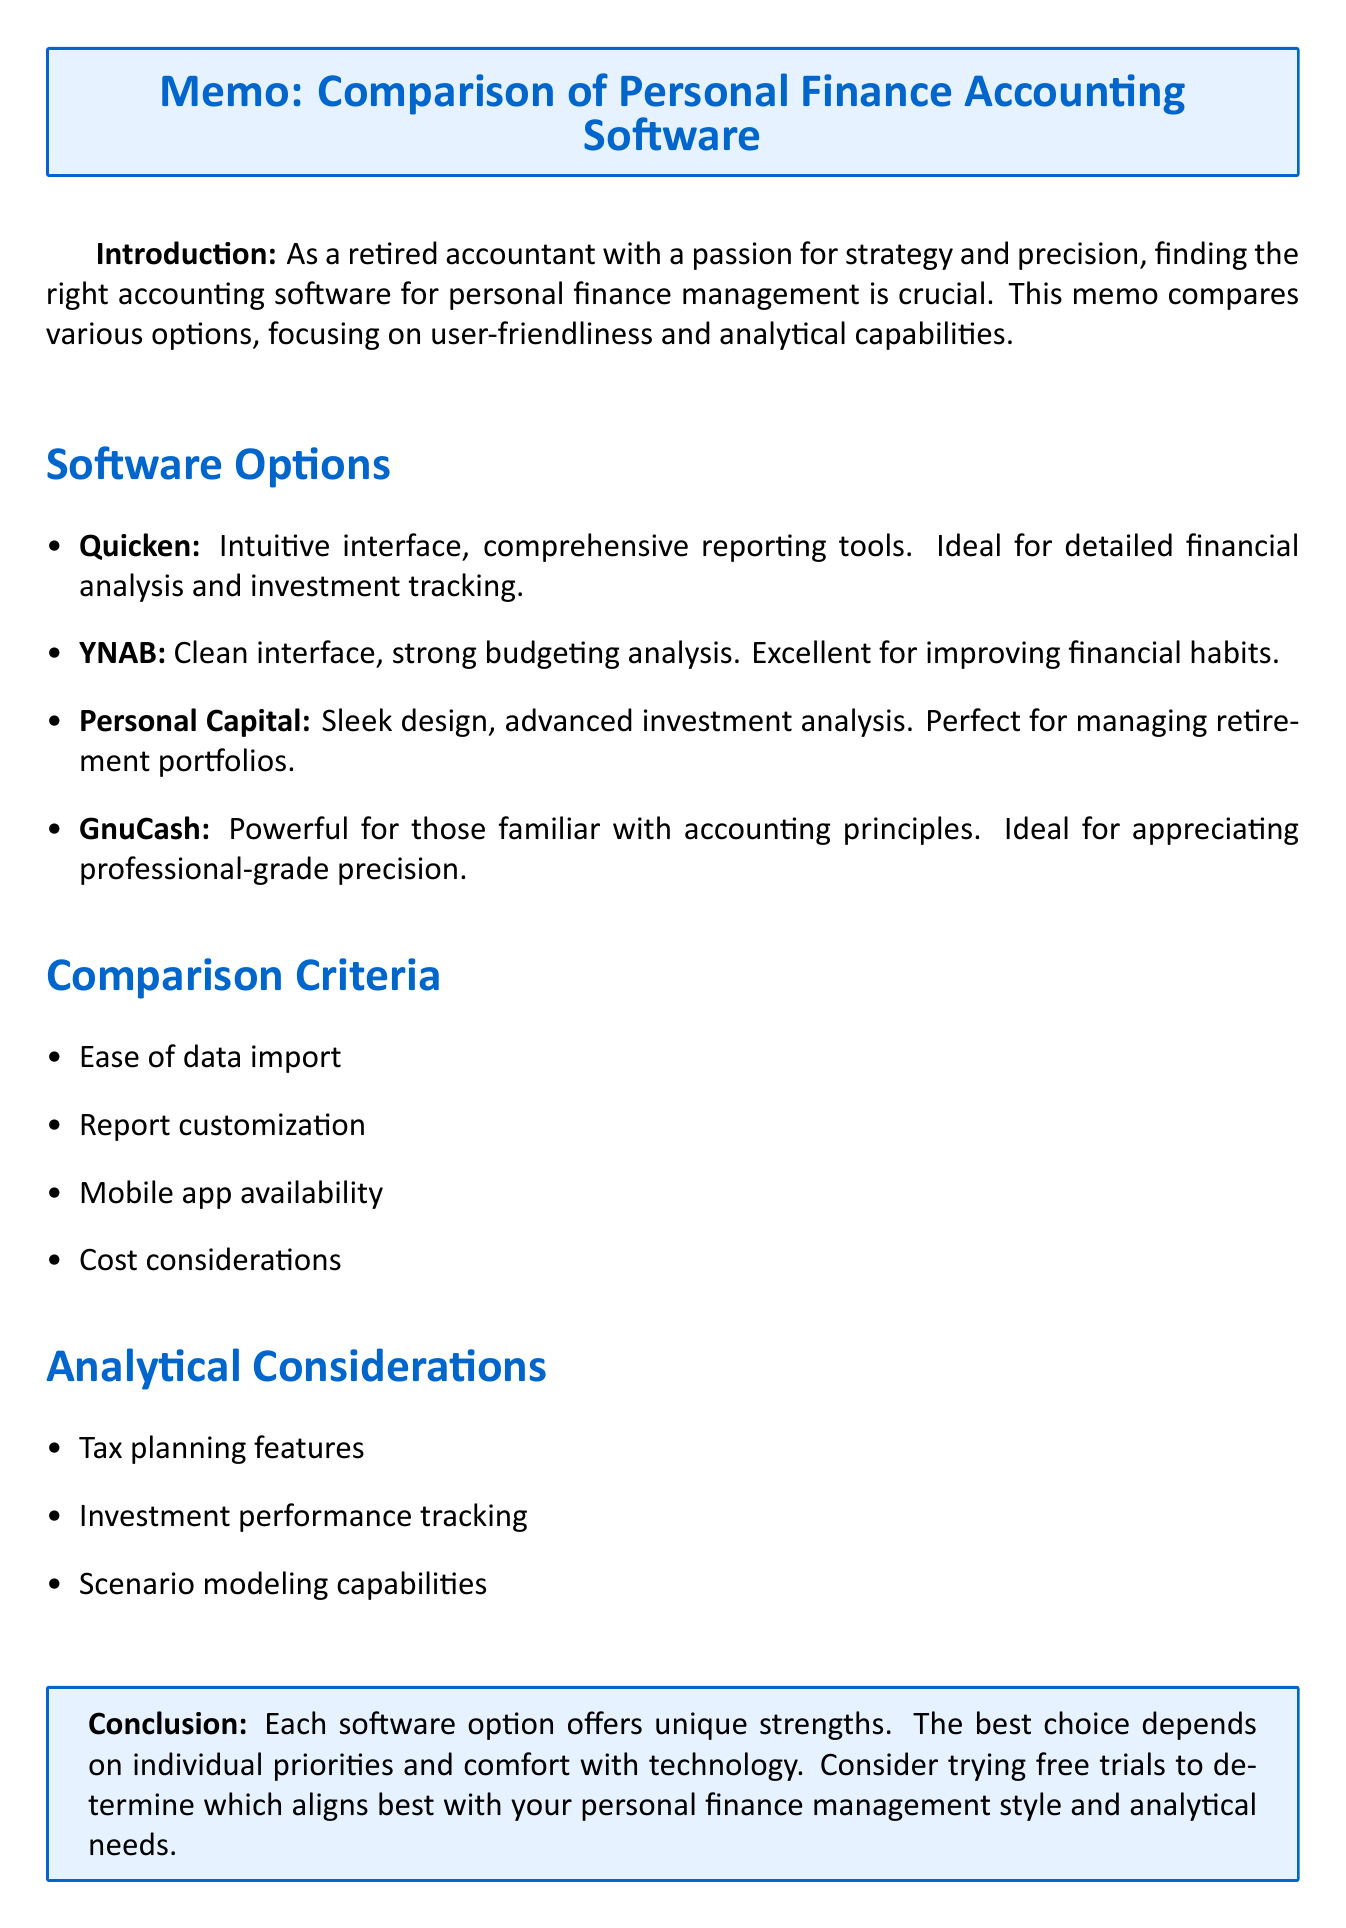What is the main focus of the memo? The main focus of the memo is a comparison of various accounting software options for personal finance management, emphasizing user-friendliness and analytical capabilities.
Answer: user-friendliness and analytical capabilities Which software option is ideal for retirees focused on managing investments? The software option that is perfect for retirees focused on managing and optimizing their investment portfolio is stated directly in the document.
Answer: Personal Capital What is a key feature of YNAB? A key feature of YNAB is explicitly mentioned as part of its offerings, highlighting its function in budgeting.
Answer: Zero-based budgeting system How many software options are compared in the memo? The number of software options compared is presented clearly in the section dedicated to software options.
Answer: Four What is the importance of ease of data import? The importance of ease of data import is outlined in the comparison criteria section, indicating its role in financial management.
Answer: Crucial for efficiently transferring existing financial records Which analytical consideration is relevant for managing tax liabilities? The relevance of tax planning features in the context of the document connects to managing tax liabilities.
Answer: Tax planning features What does the conclusion recommend? The recommendation in the conclusion section suggests a specific course of action for better software selection.
Answer: Consider trying free trials What type of interface does Quicken offer? The type of interface offered by Quicken is described positively in the software options section.
Answer: Intuitive interface 